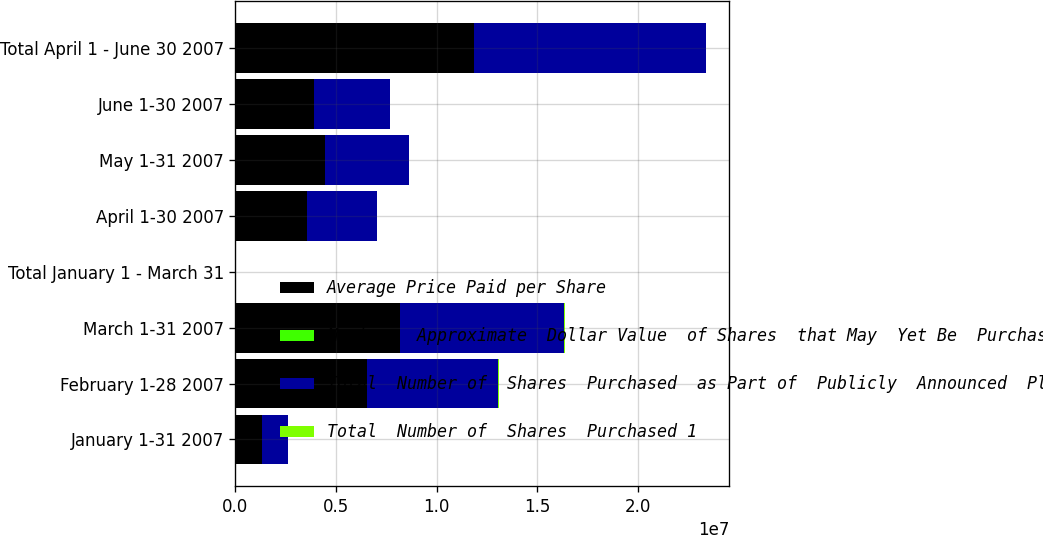Convert chart. <chart><loc_0><loc_0><loc_500><loc_500><stacked_bar_chart><ecel><fcel>January 1-31 2007<fcel>February 1-28 2007<fcel>March 1-31 2007<fcel>Total January 1 - March 31<fcel>April 1-30 2007<fcel>May 1-31 2007<fcel>June 1-30 2007<fcel>Total April 1 - June 30 2007<nl><fcel>Average Price Paid per Share<fcel>1.31127e+06<fcel>6.54259e+06<fcel>8.18747e+06<fcel>6423<fcel>3.54822e+06<fcel>4.42822e+06<fcel>3.88503e+06<fcel>1.18615e+07<nl><fcel>Maximum  Approximate  Dollar Value  of Shares  that May  Yet Be  Purchased  under the  Plans or  Programs  Millions<fcel>76.33<fcel>75.12<fcel>75.59<fcel>75.46<fcel>77.55<fcel>85.84<fcel>86.58<fcel>83.6<nl><fcel>Total  Number of  Shares  Purchased  as Part of  Publicly  Announced  Plans or  Programs<fcel>1.2772e+06<fcel>6.5225e+06<fcel>8.1517e+06<fcel>6423<fcel>3.4767e+06<fcel>4.2028e+06<fcel>3.8108e+06<fcel>1.14903e+07<nl><fcel>Total  Number of  Shares  Purchased 1<fcel>651<fcel>6731<fcel>6115<fcel>6115<fcel>5846<fcel>5485<fcel>5155<fcel>5155<nl></chart> 